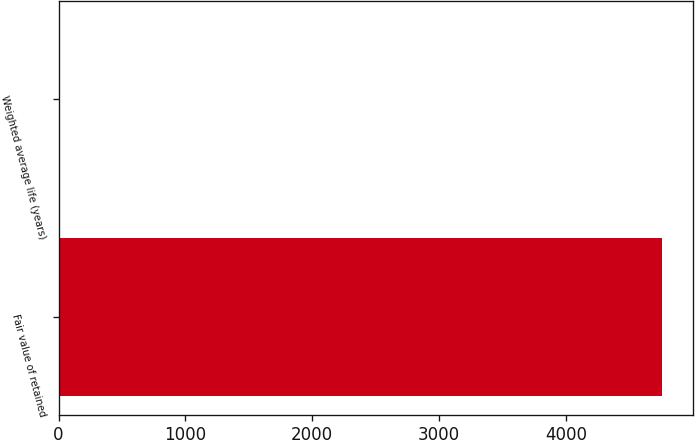<chart> <loc_0><loc_0><loc_500><loc_500><bar_chart><fcel>Fair value of retained<fcel>Weighted average life (years)<nl><fcel>4761<fcel>8.2<nl></chart> 